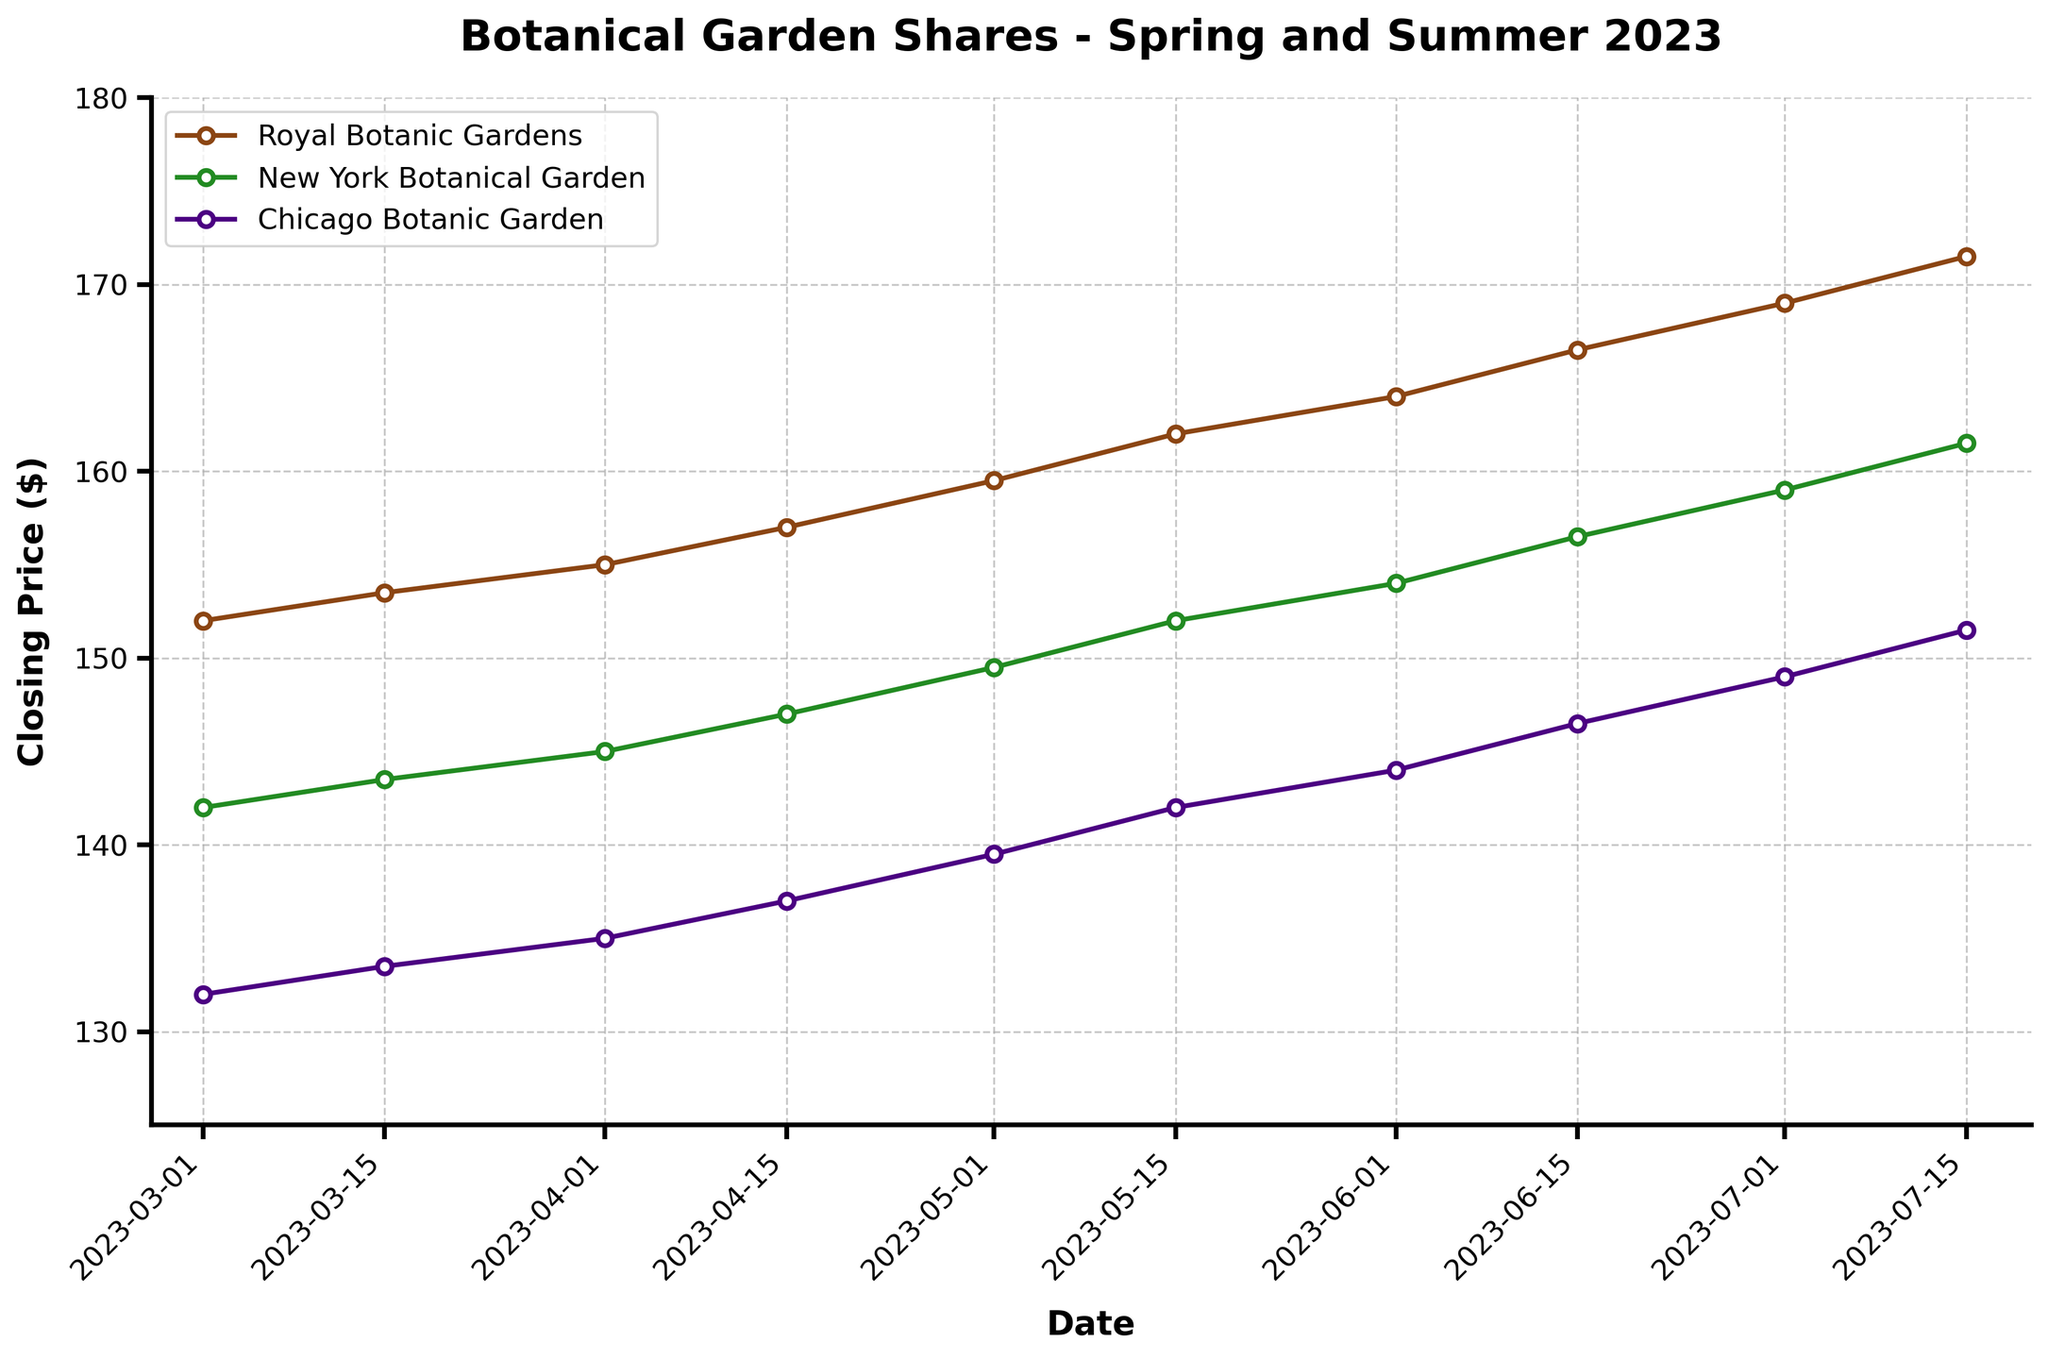What is the title of the plot? The title of the plot is usually the text at the top of the figure that describes what the plot is about. Here, it is "Botanical Garden Shares - Spring and Summer 2023" as noted in the code.
Answer: Botanical Garden Shares - Spring and Summer 2023 Which company had the highest closing price on July 15, 2023? To find this, look at the data points for July 15, 2023, and compare the closing prices for each company. Royal Botanic Gardens had a closing price of 171.5, New York Botanical Garden had 161.5, and Chicago Botanic Garden had 151.5.
Answer: Royal Botanic Gardens How many times does the closing price of the New York Botanical Garden exceed $150 during the observed period? Look through the plotted data points for the New York Botanical Garden and count the instances where the closing price was above $150. The dates are May 15, June 1, June 15, July 1, and July 15.
Answer: 5 What is the average closing price of the Royal Botanic Gardens in May 2023? First, find the closing prices for May 2023, which are $159.5 on May 1 and $162.0 on May 15. Then, calculate the average: (159.5 + 162.0) / 2 = 160.75.
Answer: 160.75 During which month did the Chicago Botanic Garden have the largest increase in closing price from the start to the end of the month? To determine this, look at the difference in closing prices from the beginning and end of each month for the Chicago Botanic Garden. Compare the differences and note that July had the largest increase: from 146.5 on July 1 to 151.5 on July 15, an increase of 5.0.
Answer: July Which botanical garden shows a consistent upward trend in its closing prices? By visually examining the trend lines for each botanical garden, the Royal Botanic Gardens show a clear and consistent upward trend in its closing prices.
Answer: Royal Botanic Gardens Estimate the closing price for the Royal Botanic Gardens on June 1, 2023, and compare it with the actual closing price. Locate June 1, 2023, on the x-axis and observe the corresponding y-axis value for the closing price of the Royal Botanic Gardens. The actual closing price is $164.0. Estimating from the plot might give a similar value.
Answer: 164.0 Сalculate the overall percentage increase in the closing price for the New York Botanical Garden from March 1, 2023, to July 15, 2023. First, find the closing prices on these dates: $142.0 on March 1 and $161.5 on July 15. Then, use the formula [(161.5 - 142.0) / 142.0] * 100% to get the percentage increase, which is approximately 13.77%.
Answer: 13.77% What is the trend observed in the volume of shares traded for the Royal Botanic Gardens from May to July? Look at the volume data points plotted for May, June, and July, and observe their trend. The volumes are increasing, from 15000 in May to 17000 in July.
Answer: Increasing 